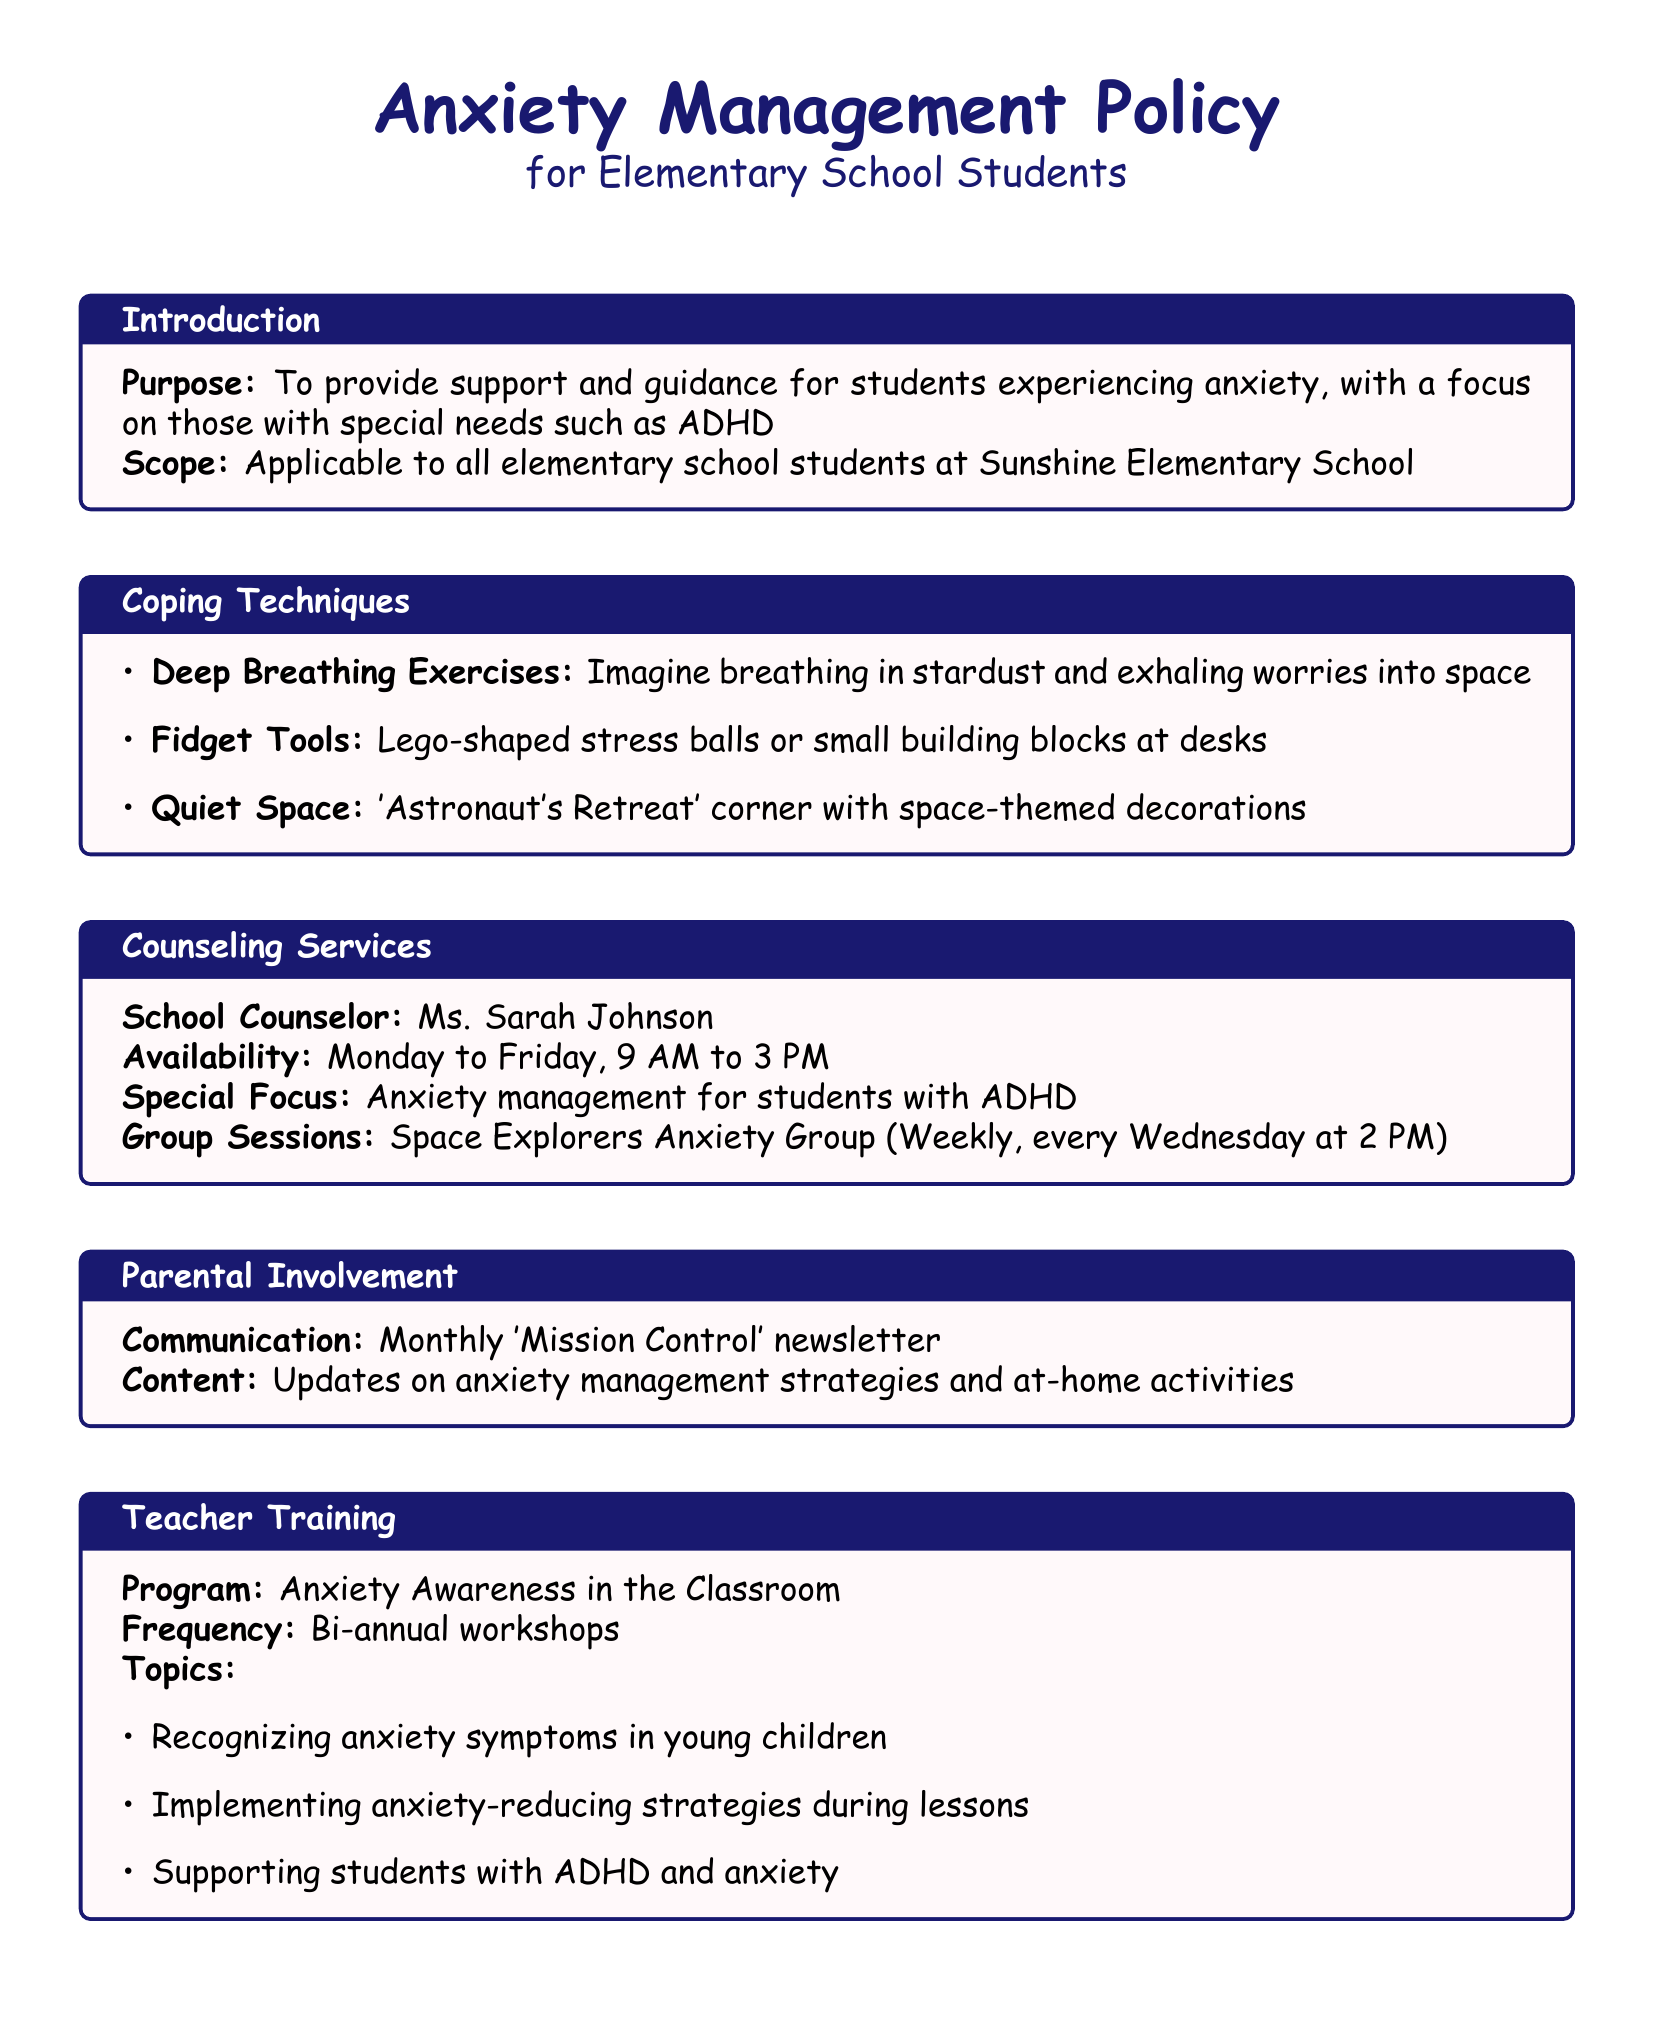What is the name of the school counselor? The document specifies Ms. Sarah Johnson as the school counselor.
Answer: Ms. Sarah Johnson When are the group sessions held? The document states that the group sessions occur every Wednesday at 2 PM.
Answer: Every Wednesday at 2 PM What is one coping technique mentioned? The document lists deep breathing exercises as one coping technique.
Answer: Deep Breathing Exercises What is the purpose of the anxiety management policy? The purpose is to provide support and guidance for students experiencing anxiety.
Answer: To provide support and guidance How often are teacher training workshops conducted? The document mentions that the workshops are bi-annual.
Answer: Bi-annual What is the special focus of the counseling services? The document highlights anxiety management for students with ADHD.
Answer: Anxiety management for students with ADHD What is the 'Astronaut's Retreat'? The document describes it as a quiet space with space-themed decorations.
Answer: A quiet space with space-themed decorations What is the content of the 'Mission Control' newsletter? The newsletter contains updates on anxiety management strategies and at-home activities.
Answer: Updates on anxiety management strategies and at-home activities 